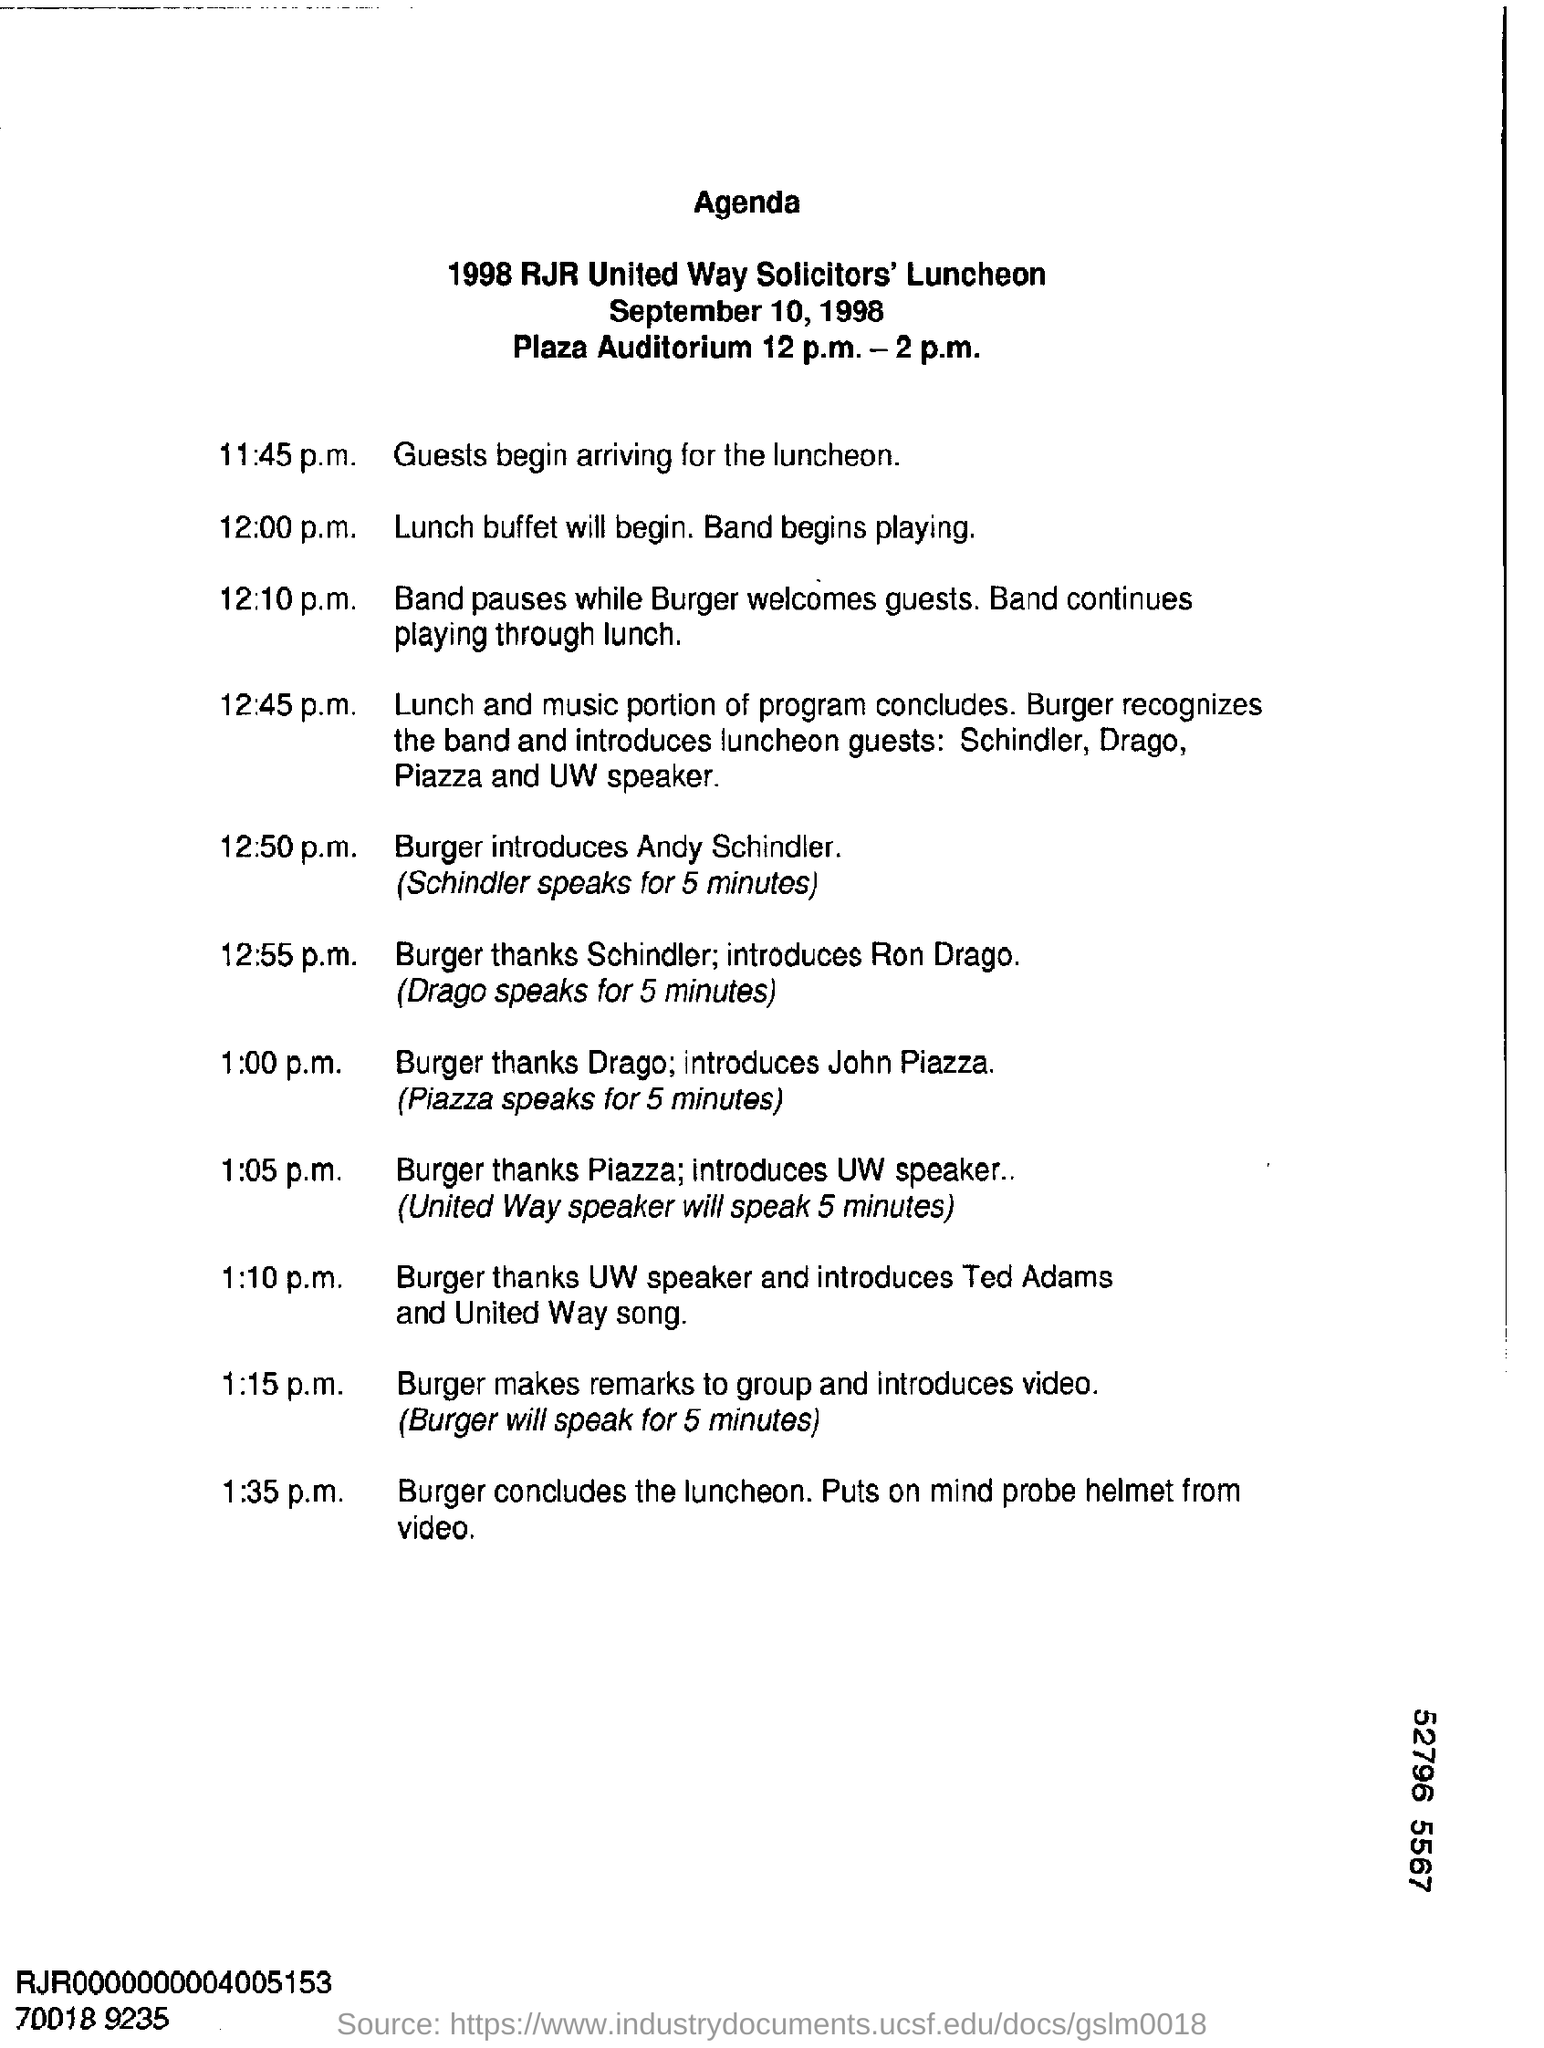On what date is the 1998 RJR United Way Solicitor's Luncheon?
Your response must be concise. September 10, 1998. When will Burger introduce Andy Schindler?
Ensure brevity in your answer.  12:50 p.m. 